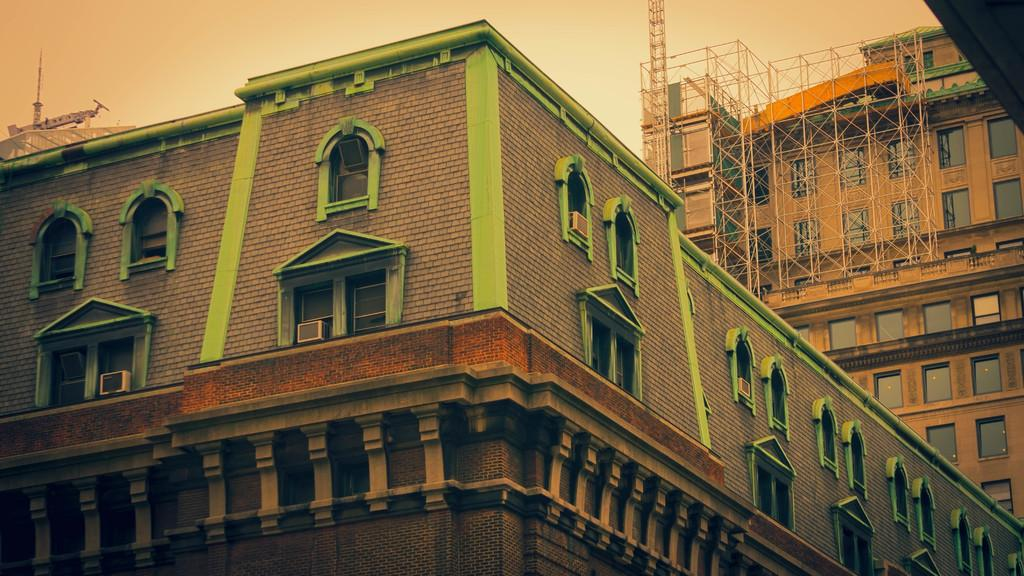What type of structures can be seen in the image? There are buildings in the image. Can you describe any specific features or objects in the background? Yes, there is a crane in the background towards the left. What type of pin can be seen in the image? There is no pin present in the image. What observation can be made about the feelings of the buildings in the image? Buildings do not have feelings, so this question cannot be answered. 